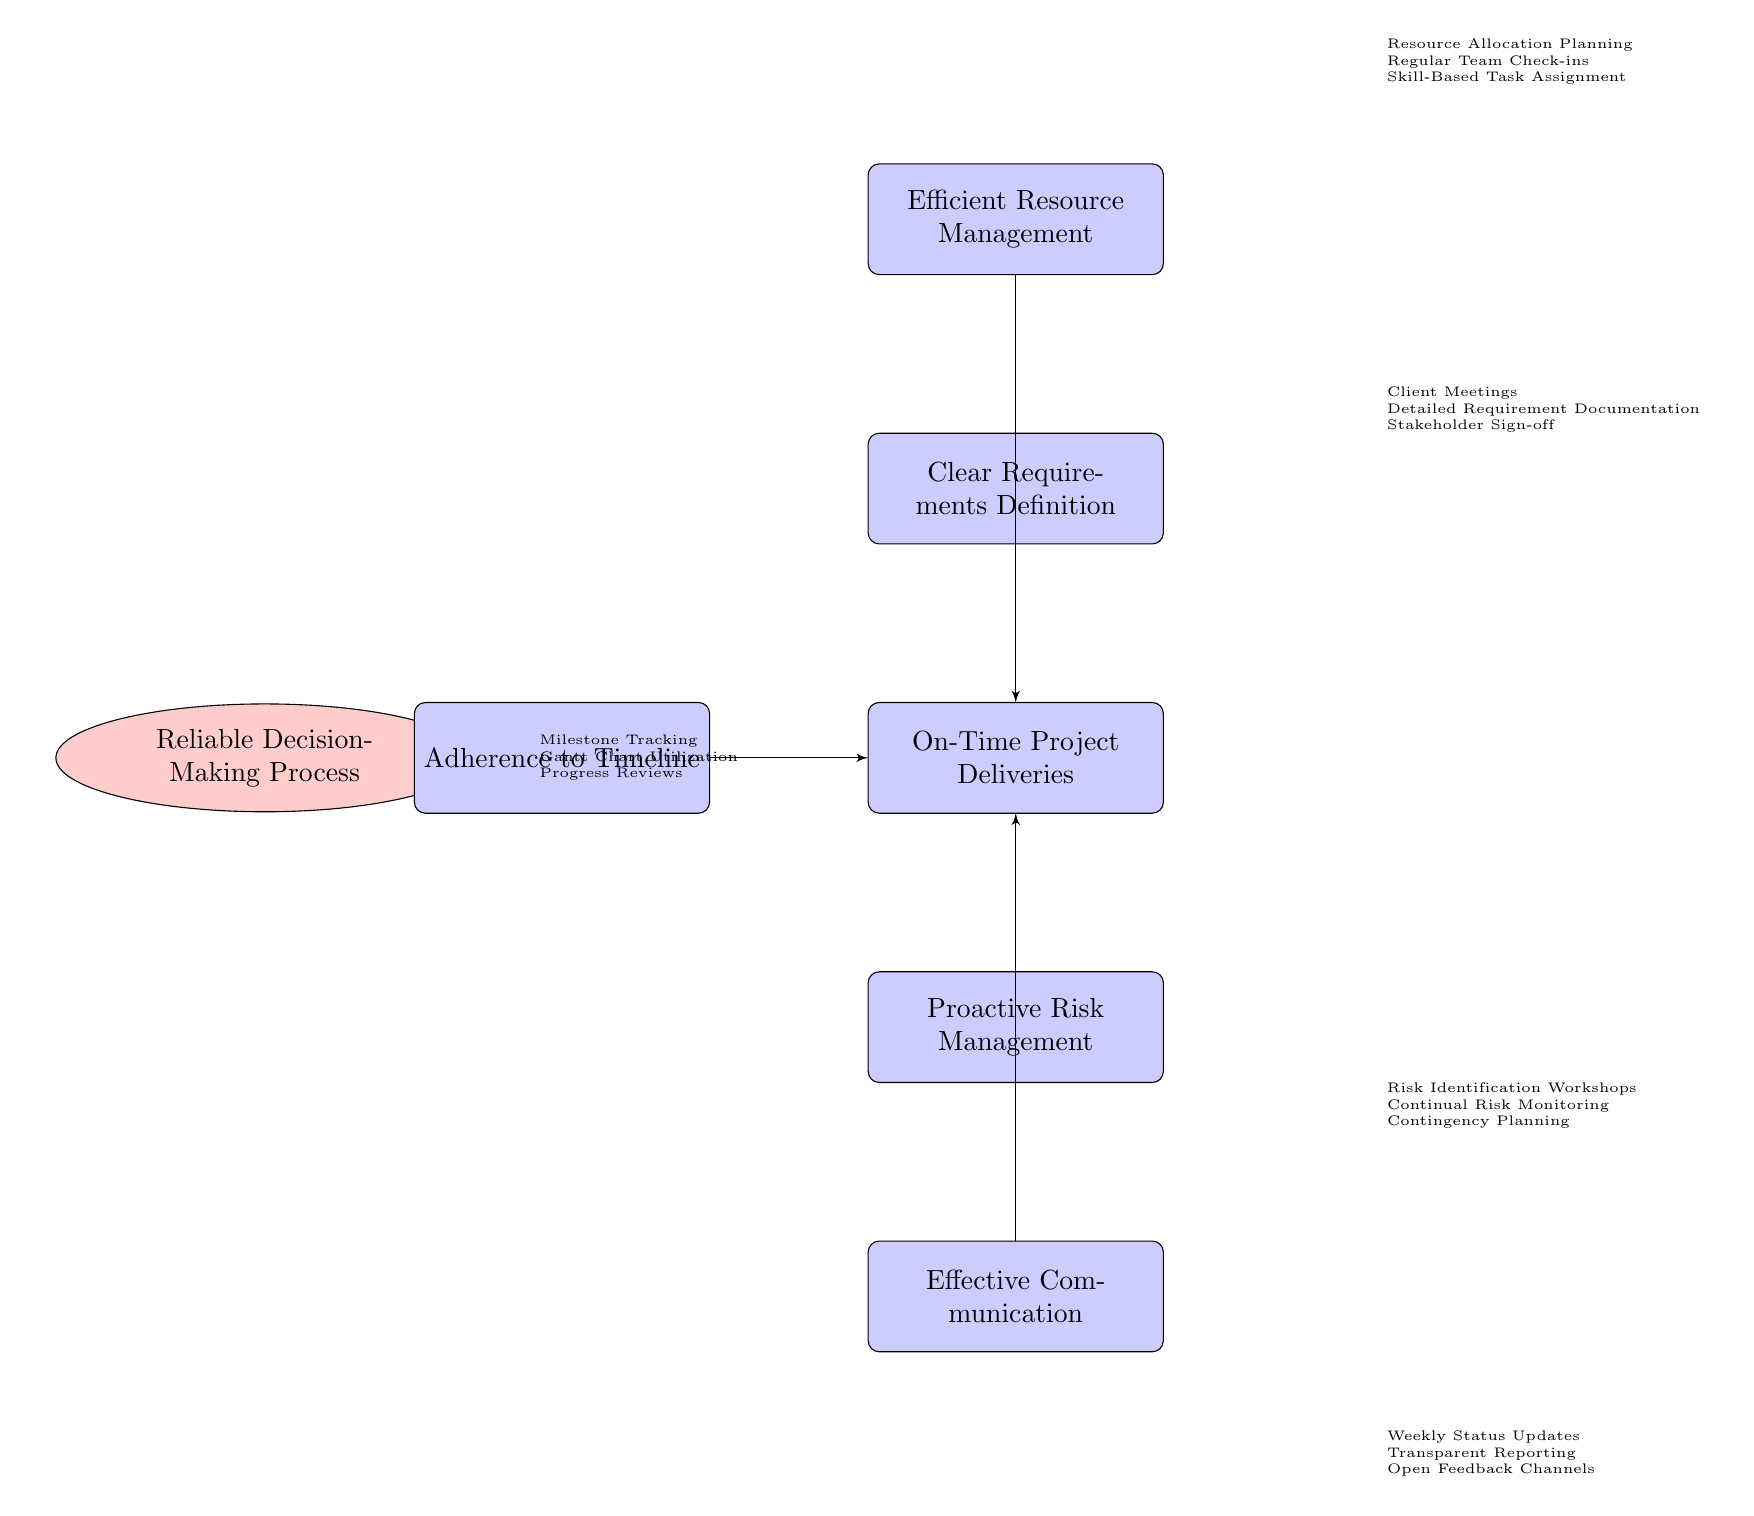What is the main topic of the diagram? The main topic is indicated at the top of the diagram as the "Reliable Decision-Making Process." This can be directly identified as the first node in the cloud shape.
Answer: Reliable Decision-Making Process How many causes lead to the effect? The diagram has five blocks labeled as causes, and each is connected to the effect. Counting these blocks confirms this number.
Answer: 5 What is the effect shown in the diagram? The effect is clearly labeled on the right side of the diagram and indicates the results of the causes listed. It is "On-Time Project Deliveries."
Answer: On-Time Project Deliveries Which cause is related to communication? The cause related to communication is located below the effect and is labeled as "Effective Communication." This can be identified by finding the block directly associated with communication strategies.
Answer: Effective Communication What specific cause involves risk management? The cause tied to risk management appears below the effect and is specifically labeled "Proactive Risk Management." It is a straightforward identification of a block discussing risks.
Answer: Proactive Risk Management How does "Clear Requirements Definition" contribute to the effect? "Clear Requirements Definition" is one of the identified causes leading into the effect of "On-Time Project Deliveries." This implies that having clarity in requirements is essential for timely deliveries.
Answer: It contributes positively Which cause emphasizes time management with a specific method? The cause emphasizing time management is "Adherence to Timeline," which suggests a focus on sticking to planned schedules, using Gantt charts, and tracking milestones as methods.
Answer: Adherence to Timeline What is a method under "Efficient Resource Management"? One method under "Efficient Resource Management" is "Resource Allocation Planning," which is a specific phase involved in managing resources effectively. This can be derived from the associated elements listed beside it.
Answer: Resource Allocation Planning How is the flow of the diagram structured? The diagram flows from the main topic at the top, indicating that the reliable decision-making process influences multiple causes, which then lead to a single effect. This structure demonstrates a cause-and-effect relationship visually.
Answer: From main to causes to effect Which cause has the most direct link to client interaction? The cause most directly linked to client interaction is "Clear Requirements Definition," specifically indicated by its association with activities like "Client Meetings" that rely on stakeholder engagement.
Answer: Clear Requirements Definition 